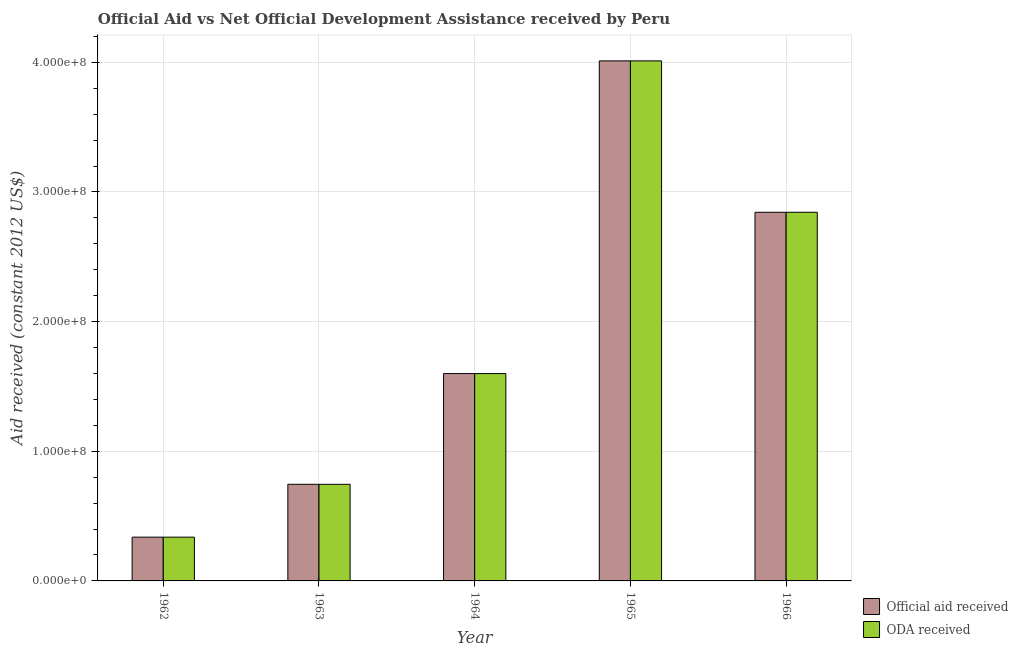How many different coloured bars are there?
Make the answer very short. 2. How many groups of bars are there?
Give a very brief answer. 5. What is the label of the 5th group of bars from the left?
Your answer should be compact. 1966. What is the oda received in 1966?
Offer a terse response. 2.84e+08. Across all years, what is the maximum oda received?
Give a very brief answer. 4.01e+08. Across all years, what is the minimum official aid received?
Make the answer very short. 3.38e+07. In which year was the official aid received maximum?
Keep it short and to the point. 1965. In which year was the oda received minimum?
Offer a very short reply. 1962. What is the total official aid received in the graph?
Offer a terse response. 9.54e+08. What is the difference between the official aid received in 1964 and that in 1966?
Offer a terse response. -1.24e+08. What is the difference between the oda received in 1964 and the official aid received in 1966?
Your response must be concise. -1.24e+08. What is the average official aid received per year?
Offer a terse response. 1.91e+08. In how many years, is the oda received greater than 300000000 US$?
Provide a short and direct response. 1. What is the ratio of the oda received in 1965 to that in 1966?
Your answer should be very brief. 1.41. Is the oda received in 1964 less than that in 1966?
Make the answer very short. Yes. Is the difference between the official aid received in 1962 and 1964 greater than the difference between the oda received in 1962 and 1964?
Provide a succinct answer. No. What is the difference between the highest and the second highest oda received?
Give a very brief answer. 1.17e+08. What is the difference between the highest and the lowest official aid received?
Ensure brevity in your answer.  3.67e+08. Is the sum of the oda received in 1963 and 1965 greater than the maximum official aid received across all years?
Offer a terse response. Yes. What does the 1st bar from the left in 1964 represents?
Give a very brief answer. Official aid received. What does the 1st bar from the right in 1964 represents?
Offer a very short reply. ODA received. Are all the bars in the graph horizontal?
Your answer should be compact. No. How many years are there in the graph?
Ensure brevity in your answer.  5. What is the difference between two consecutive major ticks on the Y-axis?
Give a very brief answer. 1.00e+08. Are the values on the major ticks of Y-axis written in scientific E-notation?
Keep it short and to the point. Yes. Does the graph contain grids?
Make the answer very short. Yes. How many legend labels are there?
Provide a short and direct response. 2. How are the legend labels stacked?
Give a very brief answer. Vertical. What is the title of the graph?
Your response must be concise. Official Aid vs Net Official Development Assistance received by Peru . Does "Private creditors" appear as one of the legend labels in the graph?
Your response must be concise. No. What is the label or title of the Y-axis?
Your response must be concise. Aid received (constant 2012 US$). What is the Aid received (constant 2012 US$) of Official aid received in 1962?
Make the answer very short. 3.38e+07. What is the Aid received (constant 2012 US$) of ODA received in 1962?
Keep it short and to the point. 3.38e+07. What is the Aid received (constant 2012 US$) of Official aid received in 1963?
Offer a very short reply. 7.45e+07. What is the Aid received (constant 2012 US$) in ODA received in 1963?
Give a very brief answer. 7.45e+07. What is the Aid received (constant 2012 US$) in Official aid received in 1964?
Keep it short and to the point. 1.60e+08. What is the Aid received (constant 2012 US$) in ODA received in 1964?
Make the answer very short. 1.60e+08. What is the Aid received (constant 2012 US$) in Official aid received in 1965?
Your answer should be compact. 4.01e+08. What is the Aid received (constant 2012 US$) of ODA received in 1965?
Offer a terse response. 4.01e+08. What is the Aid received (constant 2012 US$) of Official aid received in 1966?
Your answer should be very brief. 2.84e+08. What is the Aid received (constant 2012 US$) in ODA received in 1966?
Provide a short and direct response. 2.84e+08. Across all years, what is the maximum Aid received (constant 2012 US$) of Official aid received?
Offer a terse response. 4.01e+08. Across all years, what is the maximum Aid received (constant 2012 US$) of ODA received?
Provide a short and direct response. 4.01e+08. Across all years, what is the minimum Aid received (constant 2012 US$) of Official aid received?
Ensure brevity in your answer.  3.38e+07. Across all years, what is the minimum Aid received (constant 2012 US$) in ODA received?
Ensure brevity in your answer.  3.38e+07. What is the total Aid received (constant 2012 US$) in Official aid received in the graph?
Provide a short and direct response. 9.54e+08. What is the total Aid received (constant 2012 US$) of ODA received in the graph?
Keep it short and to the point. 9.54e+08. What is the difference between the Aid received (constant 2012 US$) in Official aid received in 1962 and that in 1963?
Provide a short and direct response. -4.08e+07. What is the difference between the Aid received (constant 2012 US$) of ODA received in 1962 and that in 1963?
Offer a very short reply. -4.08e+07. What is the difference between the Aid received (constant 2012 US$) in Official aid received in 1962 and that in 1964?
Provide a short and direct response. -1.26e+08. What is the difference between the Aid received (constant 2012 US$) of ODA received in 1962 and that in 1964?
Offer a terse response. -1.26e+08. What is the difference between the Aid received (constant 2012 US$) in Official aid received in 1962 and that in 1965?
Your answer should be compact. -3.67e+08. What is the difference between the Aid received (constant 2012 US$) of ODA received in 1962 and that in 1965?
Give a very brief answer. -3.67e+08. What is the difference between the Aid received (constant 2012 US$) of Official aid received in 1962 and that in 1966?
Your answer should be very brief. -2.51e+08. What is the difference between the Aid received (constant 2012 US$) of ODA received in 1962 and that in 1966?
Ensure brevity in your answer.  -2.51e+08. What is the difference between the Aid received (constant 2012 US$) in Official aid received in 1963 and that in 1964?
Offer a very short reply. -8.54e+07. What is the difference between the Aid received (constant 2012 US$) in ODA received in 1963 and that in 1964?
Your answer should be very brief. -8.54e+07. What is the difference between the Aid received (constant 2012 US$) of Official aid received in 1963 and that in 1965?
Your response must be concise. -3.27e+08. What is the difference between the Aid received (constant 2012 US$) of ODA received in 1963 and that in 1965?
Give a very brief answer. -3.27e+08. What is the difference between the Aid received (constant 2012 US$) in Official aid received in 1963 and that in 1966?
Your answer should be compact. -2.10e+08. What is the difference between the Aid received (constant 2012 US$) of ODA received in 1963 and that in 1966?
Ensure brevity in your answer.  -2.10e+08. What is the difference between the Aid received (constant 2012 US$) of Official aid received in 1964 and that in 1965?
Provide a short and direct response. -2.41e+08. What is the difference between the Aid received (constant 2012 US$) of ODA received in 1964 and that in 1965?
Make the answer very short. -2.41e+08. What is the difference between the Aid received (constant 2012 US$) of Official aid received in 1964 and that in 1966?
Keep it short and to the point. -1.24e+08. What is the difference between the Aid received (constant 2012 US$) of ODA received in 1964 and that in 1966?
Offer a terse response. -1.24e+08. What is the difference between the Aid received (constant 2012 US$) in Official aid received in 1965 and that in 1966?
Offer a terse response. 1.17e+08. What is the difference between the Aid received (constant 2012 US$) of ODA received in 1965 and that in 1966?
Provide a short and direct response. 1.17e+08. What is the difference between the Aid received (constant 2012 US$) in Official aid received in 1962 and the Aid received (constant 2012 US$) in ODA received in 1963?
Ensure brevity in your answer.  -4.08e+07. What is the difference between the Aid received (constant 2012 US$) of Official aid received in 1962 and the Aid received (constant 2012 US$) of ODA received in 1964?
Your response must be concise. -1.26e+08. What is the difference between the Aid received (constant 2012 US$) of Official aid received in 1962 and the Aid received (constant 2012 US$) of ODA received in 1965?
Give a very brief answer. -3.67e+08. What is the difference between the Aid received (constant 2012 US$) of Official aid received in 1962 and the Aid received (constant 2012 US$) of ODA received in 1966?
Make the answer very short. -2.51e+08. What is the difference between the Aid received (constant 2012 US$) in Official aid received in 1963 and the Aid received (constant 2012 US$) in ODA received in 1964?
Your response must be concise. -8.54e+07. What is the difference between the Aid received (constant 2012 US$) in Official aid received in 1963 and the Aid received (constant 2012 US$) in ODA received in 1965?
Make the answer very short. -3.27e+08. What is the difference between the Aid received (constant 2012 US$) in Official aid received in 1963 and the Aid received (constant 2012 US$) in ODA received in 1966?
Your answer should be compact. -2.10e+08. What is the difference between the Aid received (constant 2012 US$) of Official aid received in 1964 and the Aid received (constant 2012 US$) of ODA received in 1965?
Keep it short and to the point. -2.41e+08. What is the difference between the Aid received (constant 2012 US$) of Official aid received in 1964 and the Aid received (constant 2012 US$) of ODA received in 1966?
Keep it short and to the point. -1.24e+08. What is the difference between the Aid received (constant 2012 US$) of Official aid received in 1965 and the Aid received (constant 2012 US$) of ODA received in 1966?
Offer a terse response. 1.17e+08. What is the average Aid received (constant 2012 US$) in Official aid received per year?
Offer a terse response. 1.91e+08. What is the average Aid received (constant 2012 US$) of ODA received per year?
Ensure brevity in your answer.  1.91e+08. In the year 1963, what is the difference between the Aid received (constant 2012 US$) in Official aid received and Aid received (constant 2012 US$) in ODA received?
Provide a short and direct response. 0. In the year 1964, what is the difference between the Aid received (constant 2012 US$) of Official aid received and Aid received (constant 2012 US$) of ODA received?
Your answer should be compact. 0. In the year 1965, what is the difference between the Aid received (constant 2012 US$) of Official aid received and Aid received (constant 2012 US$) of ODA received?
Keep it short and to the point. 0. In the year 1966, what is the difference between the Aid received (constant 2012 US$) in Official aid received and Aid received (constant 2012 US$) in ODA received?
Ensure brevity in your answer.  0. What is the ratio of the Aid received (constant 2012 US$) in Official aid received in 1962 to that in 1963?
Make the answer very short. 0.45. What is the ratio of the Aid received (constant 2012 US$) of ODA received in 1962 to that in 1963?
Offer a very short reply. 0.45. What is the ratio of the Aid received (constant 2012 US$) in Official aid received in 1962 to that in 1964?
Provide a succinct answer. 0.21. What is the ratio of the Aid received (constant 2012 US$) in ODA received in 1962 to that in 1964?
Ensure brevity in your answer.  0.21. What is the ratio of the Aid received (constant 2012 US$) in Official aid received in 1962 to that in 1965?
Keep it short and to the point. 0.08. What is the ratio of the Aid received (constant 2012 US$) in ODA received in 1962 to that in 1965?
Offer a very short reply. 0.08. What is the ratio of the Aid received (constant 2012 US$) of Official aid received in 1962 to that in 1966?
Give a very brief answer. 0.12. What is the ratio of the Aid received (constant 2012 US$) in ODA received in 1962 to that in 1966?
Provide a short and direct response. 0.12. What is the ratio of the Aid received (constant 2012 US$) of Official aid received in 1963 to that in 1964?
Offer a very short reply. 0.47. What is the ratio of the Aid received (constant 2012 US$) of ODA received in 1963 to that in 1964?
Provide a short and direct response. 0.47. What is the ratio of the Aid received (constant 2012 US$) in Official aid received in 1963 to that in 1965?
Make the answer very short. 0.19. What is the ratio of the Aid received (constant 2012 US$) of ODA received in 1963 to that in 1965?
Your answer should be very brief. 0.19. What is the ratio of the Aid received (constant 2012 US$) of Official aid received in 1963 to that in 1966?
Provide a succinct answer. 0.26. What is the ratio of the Aid received (constant 2012 US$) in ODA received in 1963 to that in 1966?
Offer a very short reply. 0.26. What is the ratio of the Aid received (constant 2012 US$) in Official aid received in 1964 to that in 1965?
Offer a terse response. 0.4. What is the ratio of the Aid received (constant 2012 US$) of ODA received in 1964 to that in 1965?
Your answer should be compact. 0.4. What is the ratio of the Aid received (constant 2012 US$) in Official aid received in 1964 to that in 1966?
Your response must be concise. 0.56. What is the ratio of the Aid received (constant 2012 US$) in ODA received in 1964 to that in 1966?
Your answer should be very brief. 0.56. What is the ratio of the Aid received (constant 2012 US$) in Official aid received in 1965 to that in 1966?
Offer a terse response. 1.41. What is the ratio of the Aid received (constant 2012 US$) in ODA received in 1965 to that in 1966?
Offer a terse response. 1.41. What is the difference between the highest and the second highest Aid received (constant 2012 US$) of Official aid received?
Your answer should be very brief. 1.17e+08. What is the difference between the highest and the second highest Aid received (constant 2012 US$) in ODA received?
Make the answer very short. 1.17e+08. What is the difference between the highest and the lowest Aid received (constant 2012 US$) in Official aid received?
Offer a terse response. 3.67e+08. What is the difference between the highest and the lowest Aid received (constant 2012 US$) in ODA received?
Offer a terse response. 3.67e+08. 